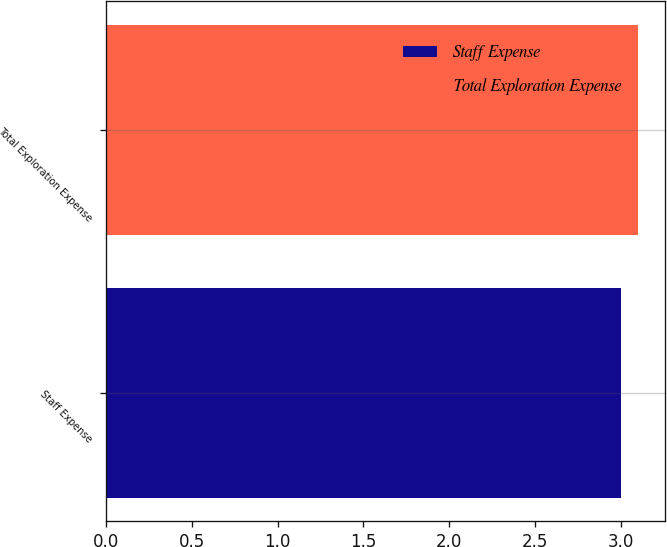Convert chart to OTSL. <chart><loc_0><loc_0><loc_500><loc_500><bar_chart><fcel>Staff Expense<fcel>Total Exploration Expense<nl><fcel>3<fcel>3.1<nl></chart> 